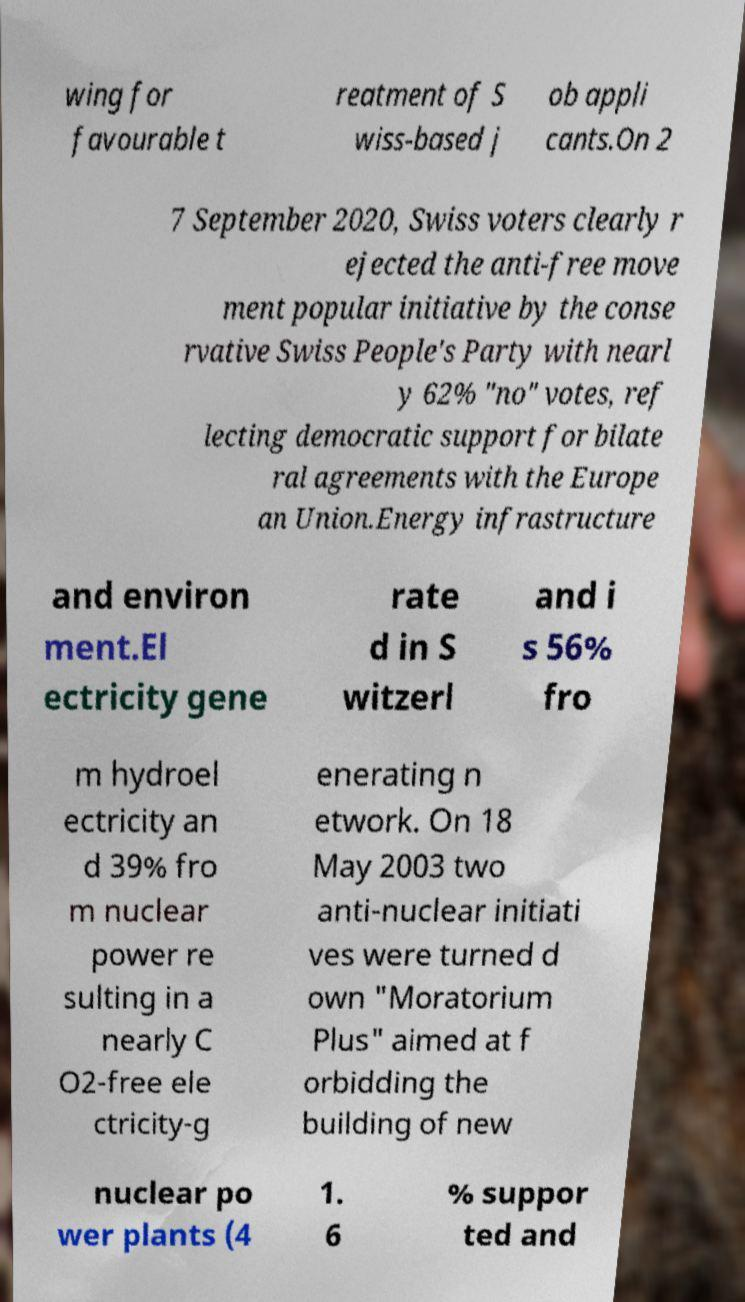Could you assist in decoding the text presented in this image and type it out clearly? wing for favourable t reatment of S wiss-based j ob appli cants.On 2 7 September 2020, Swiss voters clearly r ejected the anti-free move ment popular initiative by the conse rvative Swiss People's Party with nearl y 62% "no" votes, ref lecting democratic support for bilate ral agreements with the Europe an Union.Energy infrastructure and environ ment.El ectricity gene rate d in S witzerl and i s 56% fro m hydroel ectricity an d 39% fro m nuclear power re sulting in a nearly C O2-free ele ctricity-g enerating n etwork. On 18 May 2003 two anti-nuclear initiati ves were turned d own "Moratorium Plus" aimed at f orbidding the building of new nuclear po wer plants (4 1. 6 % suppor ted and 